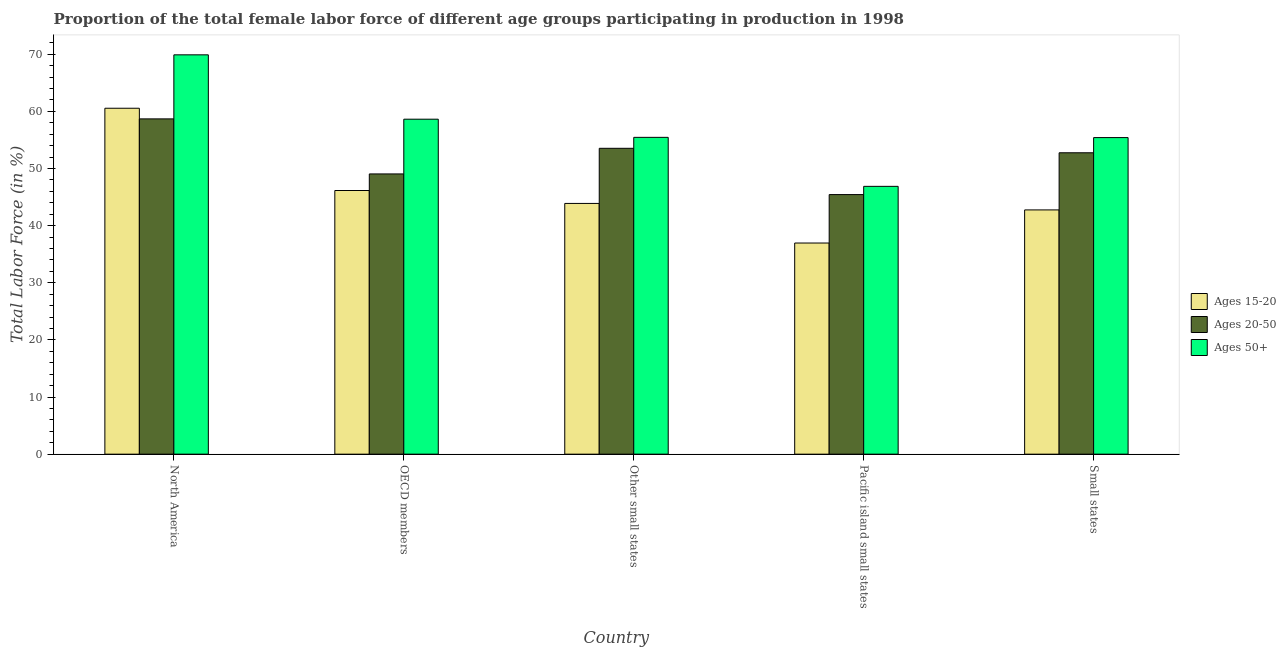Are the number of bars on each tick of the X-axis equal?
Keep it short and to the point. Yes. How many bars are there on the 1st tick from the left?
Make the answer very short. 3. What is the label of the 4th group of bars from the left?
Your response must be concise. Pacific island small states. What is the percentage of female labor force within the age group 15-20 in North America?
Provide a succinct answer. 60.55. Across all countries, what is the maximum percentage of female labor force above age 50?
Ensure brevity in your answer.  69.9. Across all countries, what is the minimum percentage of female labor force above age 50?
Offer a terse response. 46.88. In which country was the percentage of female labor force within the age group 15-20 maximum?
Keep it short and to the point. North America. In which country was the percentage of female labor force within the age group 20-50 minimum?
Make the answer very short. Pacific island small states. What is the total percentage of female labor force within the age group 20-50 in the graph?
Ensure brevity in your answer.  259.48. What is the difference between the percentage of female labor force within the age group 15-20 in Other small states and that in Small states?
Give a very brief answer. 1.13. What is the difference between the percentage of female labor force within the age group 20-50 in Small states and the percentage of female labor force within the age group 15-20 in Pacific island small states?
Give a very brief answer. 15.8. What is the average percentage of female labor force within the age group 15-20 per country?
Your response must be concise. 46.06. What is the difference between the percentage of female labor force within the age group 20-50 and percentage of female labor force within the age group 15-20 in North America?
Offer a terse response. -1.86. In how many countries, is the percentage of female labor force within the age group 15-20 greater than 48 %?
Give a very brief answer. 1. What is the ratio of the percentage of female labor force above age 50 in North America to that in OECD members?
Make the answer very short. 1.19. Is the difference between the percentage of female labor force above age 50 in North America and OECD members greater than the difference between the percentage of female labor force within the age group 20-50 in North America and OECD members?
Your answer should be very brief. Yes. What is the difference between the highest and the second highest percentage of female labor force within the age group 20-50?
Keep it short and to the point. 5.15. What is the difference between the highest and the lowest percentage of female labor force above age 50?
Keep it short and to the point. 23.02. What does the 2nd bar from the left in Small states represents?
Offer a very short reply. Ages 20-50. What does the 2nd bar from the right in Small states represents?
Offer a very short reply. Ages 20-50. Is it the case that in every country, the sum of the percentage of female labor force within the age group 15-20 and percentage of female labor force within the age group 20-50 is greater than the percentage of female labor force above age 50?
Your answer should be very brief. Yes. How many countries are there in the graph?
Provide a succinct answer. 5. What is the difference between two consecutive major ticks on the Y-axis?
Offer a terse response. 10. Does the graph contain grids?
Your answer should be very brief. No. Where does the legend appear in the graph?
Provide a succinct answer. Center right. What is the title of the graph?
Ensure brevity in your answer.  Proportion of the total female labor force of different age groups participating in production in 1998. What is the label or title of the Y-axis?
Ensure brevity in your answer.  Total Labor Force (in %). What is the Total Labor Force (in %) of Ages 15-20 in North America?
Make the answer very short. 60.55. What is the Total Labor Force (in %) in Ages 20-50 in North America?
Your answer should be very brief. 58.69. What is the Total Labor Force (in %) of Ages 50+ in North America?
Keep it short and to the point. 69.9. What is the Total Labor Force (in %) in Ages 15-20 in OECD members?
Ensure brevity in your answer.  46.15. What is the Total Labor Force (in %) of Ages 20-50 in OECD members?
Provide a short and direct response. 49.05. What is the Total Labor Force (in %) in Ages 50+ in OECD members?
Provide a short and direct response. 58.64. What is the Total Labor Force (in %) in Ages 15-20 in Other small states?
Your answer should be compact. 43.89. What is the Total Labor Force (in %) of Ages 20-50 in Other small states?
Your answer should be very brief. 53.54. What is the Total Labor Force (in %) of Ages 50+ in Other small states?
Your answer should be compact. 55.45. What is the Total Labor Force (in %) in Ages 15-20 in Pacific island small states?
Keep it short and to the point. 36.96. What is the Total Labor Force (in %) in Ages 20-50 in Pacific island small states?
Keep it short and to the point. 45.44. What is the Total Labor Force (in %) of Ages 50+ in Pacific island small states?
Offer a very short reply. 46.88. What is the Total Labor Force (in %) of Ages 15-20 in Small states?
Your response must be concise. 42.76. What is the Total Labor Force (in %) of Ages 20-50 in Small states?
Give a very brief answer. 52.76. What is the Total Labor Force (in %) in Ages 50+ in Small states?
Give a very brief answer. 55.41. Across all countries, what is the maximum Total Labor Force (in %) in Ages 15-20?
Keep it short and to the point. 60.55. Across all countries, what is the maximum Total Labor Force (in %) of Ages 20-50?
Ensure brevity in your answer.  58.69. Across all countries, what is the maximum Total Labor Force (in %) of Ages 50+?
Offer a terse response. 69.9. Across all countries, what is the minimum Total Labor Force (in %) in Ages 15-20?
Make the answer very short. 36.96. Across all countries, what is the minimum Total Labor Force (in %) of Ages 20-50?
Offer a terse response. 45.44. Across all countries, what is the minimum Total Labor Force (in %) of Ages 50+?
Keep it short and to the point. 46.88. What is the total Total Labor Force (in %) of Ages 15-20 in the graph?
Give a very brief answer. 230.31. What is the total Total Labor Force (in %) of Ages 20-50 in the graph?
Give a very brief answer. 259.48. What is the total Total Labor Force (in %) of Ages 50+ in the graph?
Give a very brief answer. 286.28. What is the difference between the Total Labor Force (in %) of Ages 15-20 in North America and that in OECD members?
Provide a short and direct response. 14.4. What is the difference between the Total Labor Force (in %) of Ages 20-50 in North America and that in OECD members?
Your answer should be very brief. 9.64. What is the difference between the Total Labor Force (in %) in Ages 50+ in North America and that in OECD members?
Offer a very short reply. 11.26. What is the difference between the Total Labor Force (in %) in Ages 15-20 in North America and that in Other small states?
Keep it short and to the point. 16.66. What is the difference between the Total Labor Force (in %) in Ages 20-50 in North America and that in Other small states?
Offer a terse response. 5.15. What is the difference between the Total Labor Force (in %) of Ages 50+ in North America and that in Other small states?
Make the answer very short. 14.44. What is the difference between the Total Labor Force (in %) in Ages 15-20 in North America and that in Pacific island small states?
Make the answer very short. 23.59. What is the difference between the Total Labor Force (in %) in Ages 20-50 in North America and that in Pacific island small states?
Make the answer very short. 13.25. What is the difference between the Total Labor Force (in %) in Ages 50+ in North America and that in Pacific island small states?
Your answer should be very brief. 23.02. What is the difference between the Total Labor Force (in %) of Ages 15-20 in North America and that in Small states?
Ensure brevity in your answer.  17.8. What is the difference between the Total Labor Force (in %) in Ages 20-50 in North America and that in Small states?
Ensure brevity in your answer.  5.93. What is the difference between the Total Labor Force (in %) in Ages 50+ in North America and that in Small states?
Provide a succinct answer. 14.48. What is the difference between the Total Labor Force (in %) of Ages 15-20 in OECD members and that in Other small states?
Make the answer very short. 2.26. What is the difference between the Total Labor Force (in %) in Ages 20-50 in OECD members and that in Other small states?
Provide a short and direct response. -4.49. What is the difference between the Total Labor Force (in %) of Ages 50+ in OECD members and that in Other small states?
Your answer should be very brief. 3.18. What is the difference between the Total Labor Force (in %) of Ages 15-20 in OECD members and that in Pacific island small states?
Make the answer very short. 9.19. What is the difference between the Total Labor Force (in %) of Ages 20-50 in OECD members and that in Pacific island small states?
Your answer should be compact. 3.62. What is the difference between the Total Labor Force (in %) of Ages 50+ in OECD members and that in Pacific island small states?
Give a very brief answer. 11.76. What is the difference between the Total Labor Force (in %) of Ages 15-20 in OECD members and that in Small states?
Keep it short and to the point. 3.4. What is the difference between the Total Labor Force (in %) of Ages 20-50 in OECD members and that in Small states?
Your answer should be very brief. -3.7. What is the difference between the Total Labor Force (in %) in Ages 50+ in OECD members and that in Small states?
Your answer should be very brief. 3.22. What is the difference between the Total Labor Force (in %) of Ages 15-20 in Other small states and that in Pacific island small states?
Keep it short and to the point. 6.93. What is the difference between the Total Labor Force (in %) in Ages 20-50 in Other small states and that in Pacific island small states?
Your answer should be very brief. 8.1. What is the difference between the Total Labor Force (in %) in Ages 50+ in Other small states and that in Pacific island small states?
Your answer should be compact. 8.58. What is the difference between the Total Labor Force (in %) in Ages 15-20 in Other small states and that in Small states?
Provide a succinct answer. 1.13. What is the difference between the Total Labor Force (in %) in Ages 20-50 in Other small states and that in Small states?
Ensure brevity in your answer.  0.78. What is the difference between the Total Labor Force (in %) of Ages 50+ in Other small states and that in Small states?
Offer a very short reply. 0.04. What is the difference between the Total Labor Force (in %) in Ages 15-20 in Pacific island small states and that in Small states?
Provide a short and direct response. -5.8. What is the difference between the Total Labor Force (in %) in Ages 20-50 in Pacific island small states and that in Small states?
Provide a succinct answer. -7.32. What is the difference between the Total Labor Force (in %) in Ages 50+ in Pacific island small states and that in Small states?
Offer a terse response. -8.54. What is the difference between the Total Labor Force (in %) in Ages 15-20 in North America and the Total Labor Force (in %) in Ages 20-50 in OECD members?
Make the answer very short. 11.5. What is the difference between the Total Labor Force (in %) of Ages 15-20 in North America and the Total Labor Force (in %) of Ages 50+ in OECD members?
Your response must be concise. 1.92. What is the difference between the Total Labor Force (in %) in Ages 20-50 in North America and the Total Labor Force (in %) in Ages 50+ in OECD members?
Offer a terse response. 0.05. What is the difference between the Total Labor Force (in %) of Ages 15-20 in North America and the Total Labor Force (in %) of Ages 20-50 in Other small states?
Provide a succinct answer. 7.01. What is the difference between the Total Labor Force (in %) of Ages 15-20 in North America and the Total Labor Force (in %) of Ages 50+ in Other small states?
Keep it short and to the point. 5.1. What is the difference between the Total Labor Force (in %) of Ages 20-50 in North America and the Total Labor Force (in %) of Ages 50+ in Other small states?
Your answer should be very brief. 3.23. What is the difference between the Total Labor Force (in %) of Ages 15-20 in North America and the Total Labor Force (in %) of Ages 20-50 in Pacific island small states?
Keep it short and to the point. 15.11. What is the difference between the Total Labor Force (in %) of Ages 15-20 in North America and the Total Labor Force (in %) of Ages 50+ in Pacific island small states?
Make the answer very short. 13.67. What is the difference between the Total Labor Force (in %) of Ages 20-50 in North America and the Total Labor Force (in %) of Ages 50+ in Pacific island small states?
Keep it short and to the point. 11.81. What is the difference between the Total Labor Force (in %) in Ages 15-20 in North America and the Total Labor Force (in %) in Ages 20-50 in Small states?
Provide a succinct answer. 7.8. What is the difference between the Total Labor Force (in %) in Ages 15-20 in North America and the Total Labor Force (in %) in Ages 50+ in Small states?
Your answer should be compact. 5.14. What is the difference between the Total Labor Force (in %) in Ages 20-50 in North America and the Total Labor Force (in %) in Ages 50+ in Small states?
Give a very brief answer. 3.28. What is the difference between the Total Labor Force (in %) in Ages 15-20 in OECD members and the Total Labor Force (in %) in Ages 20-50 in Other small states?
Ensure brevity in your answer.  -7.39. What is the difference between the Total Labor Force (in %) of Ages 15-20 in OECD members and the Total Labor Force (in %) of Ages 50+ in Other small states?
Your answer should be very brief. -9.3. What is the difference between the Total Labor Force (in %) in Ages 20-50 in OECD members and the Total Labor Force (in %) in Ages 50+ in Other small states?
Ensure brevity in your answer.  -6.4. What is the difference between the Total Labor Force (in %) in Ages 15-20 in OECD members and the Total Labor Force (in %) in Ages 20-50 in Pacific island small states?
Give a very brief answer. 0.71. What is the difference between the Total Labor Force (in %) in Ages 15-20 in OECD members and the Total Labor Force (in %) in Ages 50+ in Pacific island small states?
Make the answer very short. -0.73. What is the difference between the Total Labor Force (in %) of Ages 20-50 in OECD members and the Total Labor Force (in %) of Ages 50+ in Pacific island small states?
Offer a terse response. 2.18. What is the difference between the Total Labor Force (in %) in Ages 15-20 in OECD members and the Total Labor Force (in %) in Ages 20-50 in Small states?
Provide a succinct answer. -6.6. What is the difference between the Total Labor Force (in %) in Ages 15-20 in OECD members and the Total Labor Force (in %) in Ages 50+ in Small states?
Your answer should be very brief. -9.26. What is the difference between the Total Labor Force (in %) of Ages 20-50 in OECD members and the Total Labor Force (in %) of Ages 50+ in Small states?
Your response must be concise. -6.36. What is the difference between the Total Labor Force (in %) of Ages 15-20 in Other small states and the Total Labor Force (in %) of Ages 20-50 in Pacific island small states?
Provide a short and direct response. -1.55. What is the difference between the Total Labor Force (in %) of Ages 15-20 in Other small states and the Total Labor Force (in %) of Ages 50+ in Pacific island small states?
Offer a terse response. -2.99. What is the difference between the Total Labor Force (in %) of Ages 20-50 in Other small states and the Total Labor Force (in %) of Ages 50+ in Pacific island small states?
Ensure brevity in your answer.  6.66. What is the difference between the Total Labor Force (in %) in Ages 15-20 in Other small states and the Total Labor Force (in %) in Ages 20-50 in Small states?
Ensure brevity in your answer.  -8.87. What is the difference between the Total Labor Force (in %) of Ages 15-20 in Other small states and the Total Labor Force (in %) of Ages 50+ in Small states?
Your answer should be very brief. -11.52. What is the difference between the Total Labor Force (in %) in Ages 20-50 in Other small states and the Total Labor Force (in %) in Ages 50+ in Small states?
Offer a terse response. -1.88. What is the difference between the Total Labor Force (in %) of Ages 15-20 in Pacific island small states and the Total Labor Force (in %) of Ages 20-50 in Small states?
Your answer should be very brief. -15.8. What is the difference between the Total Labor Force (in %) of Ages 15-20 in Pacific island small states and the Total Labor Force (in %) of Ages 50+ in Small states?
Offer a very short reply. -18.46. What is the difference between the Total Labor Force (in %) in Ages 20-50 in Pacific island small states and the Total Labor Force (in %) in Ages 50+ in Small states?
Make the answer very short. -9.98. What is the average Total Labor Force (in %) in Ages 15-20 per country?
Give a very brief answer. 46.06. What is the average Total Labor Force (in %) in Ages 20-50 per country?
Provide a succinct answer. 51.9. What is the average Total Labor Force (in %) in Ages 50+ per country?
Offer a terse response. 57.26. What is the difference between the Total Labor Force (in %) in Ages 15-20 and Total Labor Force (in %) in Ages 20-50 in North America?
Offer a very short reply. 1.86. What is the difference between the Total Labor Force (in %) in Ages 15-20 and Total Labor Force (in %) in Ages 50+ in North America?
Keep it short and to the point. -9.35. What is the difference between the Total Labor Force (in %) of Ages 20-50 and Total Labor Force (in %) of Ages 50+ in North America?
Ensure brevity in your answer.  -11.21. What is the difference between the Total Labor Force (in %) in Ages 15-20 and Total Labor Force (in %) in Ages 20-50 in OECD members?
Your answer should be very brief. -2.9. What is the difference between the Total Labor Force (in %) in Ages 15-20 and Total Labor Force (in %) in Ages 50+ in OECD members?
Provide a short and direct response. -12.48. What is the difference between the Total Labor Force (in %) of Ages 20-50 and Total Labor Force (in %) of Ages 50+ in OECD members?
Your response must be concise. -9.58. What is the difference between the Total Labor Force (in %) of Ages 15-20 and Total Labor Force (in %) of Ages 20-50 in Other small states?
Your answer should be very brief. -9.65. What is the difference between the Total Labor Force (in %) of Ages 15-20 and Total Labor Force (in %) of Ages 50+ in Other small states?
Your response must be concise. -11.56. What is the difference between the Total Labor Force (in %) of Ages 20-50 and Total Labor Force (in %) of Ages 50+ in Other small states?
Your answer should be compact. -1.92. What is the difference between the Total Labor Force (in %) of Ages 15-20 and Total Labor Force (in %) of Ages 20-50 in Pacific island small states?
Your response must be concise. -8.48. What is the difference between the Total Labor Force (in %) in Ages 15-20 and Total Labor Force (in %) in Ages 50+ in Pacific island small states?
Make the answer very short. -9.92. What is the difference between the Total Labor Force (in %) of Ages 20-50 and Total Labor Force (in %) of Ages 50+ in Pacific island small states?
Provide a succinct answer. -1.44. What is the difference between the Total Labor Force (in %) in Ages 15-20 and Total Labor Force (in %) in Ages 20-50 in Small states?
Provide a succinct answer. -10. What is the difference between the Total Labor Force (in %) in Ages 15-20 and Total Labor Force (in %) in Ages 50+ in Small states?
Your answer should be very brief. -12.66. What is the difference between the Total Labor Force (in %) of Ages 20-50 and Total Labor Force (in %) of Ages 50+ in Small states?
Your answer should be very brief. -2.66. What is the ratio of the Total Labor Force (in %) of Ages 15-20 in North America to that in OECD members?
Provide a succinct answer. 1.31. What is the ratio of the Total Labor Force (in %) in Ages 20-50 in North America to that in OECD members?
Ensure brevity in your answer.  1.2. What is the ratio of the Total Labor Force (in %) of Ages 50+ in North America to that in OECD members?
Offer a terse response. 1.19. What is the ratio of the Total Labor Force (in %) in Ages 15-20 in North America to that in Other small states?
Ensure brevity in your answer.  1.38. What is the ratio of the Total Labor Force (in %) of Ages 20-50 in North America to that in Other small states?
Offer a terse response. 1.1. What is the ratio of the Total Labor Force (in %) in Ages 50+ in North America to that in Other small states?
Give a very brief answer. 1.26. What is the ratio of the Total Labor Force (in %) in Ages 15-20 in North America to that in Pacific island small states?
Ensure brevity in your answer.  1.64. What is the ratio of the Total Labor Force (in %) of Ages 20-50 in North America to that in Pacific island small states?
Your response must be concise. 1.29. What is the ratio of the Total Labor Force (in %) of Ages 50+ in North America to that in Pacific island small states?
Your answer should be very brief. 1.49. What is the ratio of the Total Labor Force (in %) of Ages 15-20 in North America to that in Small states?
Offer a terse response. 1.42. What is the ratio of the Total Labor Force (in %) in Ages 20-50 in North America to that in Small states?
Your response must be concise. 1.11. What is the ratio of the Total Labor Force (in %) of Ages 50+ in North America to that in Small states?
Your answer should be compact. 1.26. What is the ratio of the Total Labor Force (in %) of Ages 15-20 in OECD members to that in Other small states?
Offer a very short reply. 1.05. What is the ratio of the Total Labor Force (in %) in Ages 20-50 in OECD members to that in Other small states?
Offer a terse response. 0.92. What is the ratio of the Total Labor Force (in %) in Ages 50+ in OECD members to that in Other small states?
Keep it short and to the point. 1.06. What is the ratio of the Total Labor Force (in %) in Ages 15-20 in OECD members to that in Pacific island small states?
Your answer should be very brief. 1.25. What is the ratio of the Total Labor Force (in %) of Ages 20-50 in OECD members to that in Pacific island small states?
Give a very brief answer. 1.08. What is the ratio of the Total Labor Force (in %) in Ages 50+ in OECD members to that in Pacific island small states?
Offer a very short reply. 1.25. What is the ratio of the Total Labor Force (in %) in Ages 15-20 in OECD members to that in Small states?
Your answer should be very brief. 1.08. What is the ratio of the Total Labor Force (in %) in Ages 20-50 in OECD members to that in Small states?
Your response must be concise. 0.93. What is the ratio of the Total Labor Force (in %) of Ages 50+ in OECD members to that in Small states?
Ensure brevity in your answer.  1.06. What is the ratio of the Total Labor Force (in %) in Ages 15-20 in Other small states to that in Pacific island small states?
Provide a succinct answer. 1.19. What is the ratio of the Total Labor Force (in %) in Ages 20-50 in Other small states to that in Pacific island small states?
Give a very brief answer. 1.18. What is the ratio of the Total Labor Force (in %) of Ages 50+ in Other small states to that in Pacific island small states?
Your answer should be very brief. 1.18. What is the ratio of the Total Labor Force (in %) in Ages 15-20 in Other small states to that in Small states?
Your answer should be compact. 1.03. What is the ratio of the Total Labor Force (in %) of Ages 20-50 in Other small states to that in Small states?
Make the answer very short. 1.01. What is the ratio of the Total Labor Force (in %) in Ages 15-20 in Pacific island small states to that in Small states?
Provide a short and direct response. 0.86. What is the ratio of the Total Labor Force (in %) of Ages 20-50 in Pacific island small states to that in Small states?
Make the answer very short. 0.86. What is the ratio of the Total Labor Force (in %) of Ages 50+ in Pacific island small states to that in Small states?
Your response must be concise. 0.85. What is the difference between the highest and the second highest Total Labor Force (in %) in Ages 15-20?
Your answer should be very brief. 14.4. What is the difference between the highest and the second highest Total Labor Force (in %) of Ages 20-50?
Make the answer very short. 5.15. What is the difference between the highest and the second highest Total Labor Force (in %) of Ages 50+?
Provide a succinct answer. 11.26. What is the difference between the highest and the lowest Total Labor Force (in %) of Ages 15-20?
Offer a terse response. 23.59. What is the difference between the highest and the lowest Total Labor Force (in %) of Ages 20-50?
Give a very brief answer. 13.25. What is the difference between the highest and the lowest Total Labor Force (in %) in Ages 50+?
Your answer should be very brief. 23.02. 